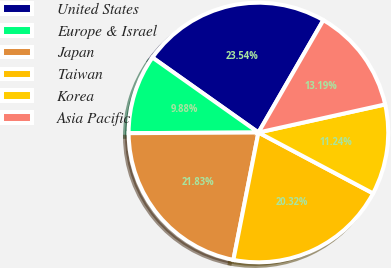<chart> <loc_0><loc_0><loc_500><loc_500><pie_chart><fcel>United States<fcel>Europe & Israel<fcel>Japan<fcel>Taiwan<fcel>Korea<fcel>Asia Pacific<nl><fcel>23.54%<fcel>9.88%<fcel>21.83%<fcel>20.32%<fcel>11.24%<fcel>13.19%<nl></chart> 